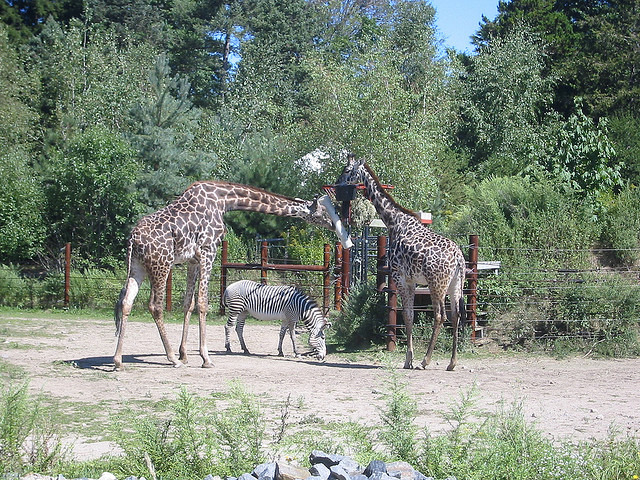What animal is between the giraffes?
A. cow
B. zebra
C. salamander
D. goose The animal standing between the giraffes is a zebra, which you can identify by its distinctive black and white striped pattern, a characteristic feature of zebras that makes them stand out among other animals. 